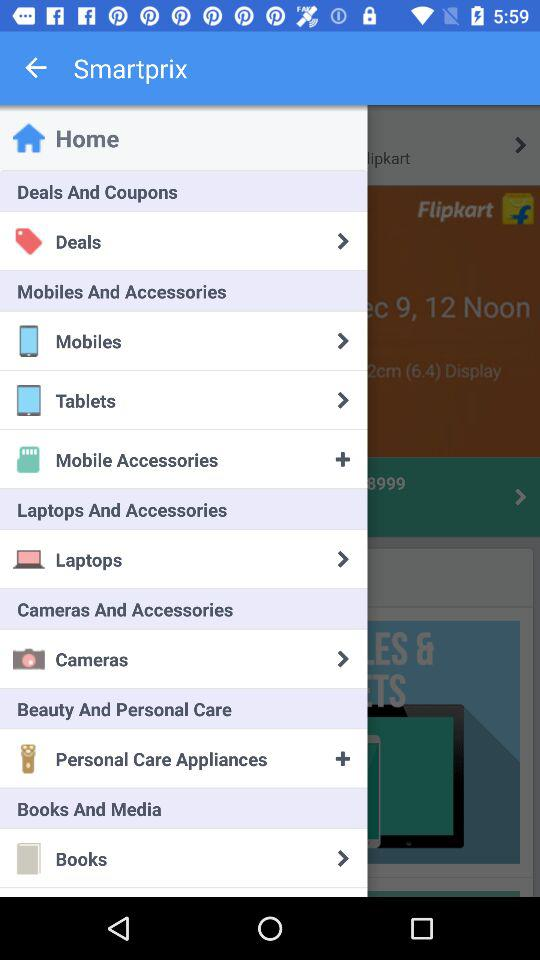What is the name of the application? The application name is "Smartprix". 